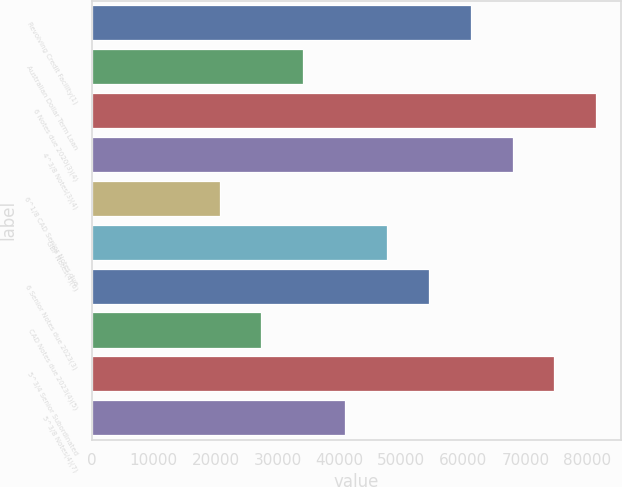Convert chart to OTSL. <chart><loc_0><loc_0><loc_500><loc_500><bar_chart><fcel>Revolving Credit Facility(1)<fcel>Australian Dollar Term Loan<fcel>6 Notes due 2020(3)(4)<fcel>4^3/8 Notes(3)(4)<fcel>6^1/8 CAD Senior Notes due<fcel>GBP Notes(4)(6)<fcel>6 Senior Notes due 2023(3)<fcel>CAD Notes due 2023(4)(5)<fcel>5^3/4 Senior Subordinated<fcel>5^3/8 Notes(4)(7)<nl><fcel>61179.9<fcel>34159.5<fcel>81445.2<fcel>67935<fcel>20649.3<fcel>47669.7<fcel>54424.8<fcel>27404.4<fcel>74690.1<fcel>40914.6<nl></chart> 